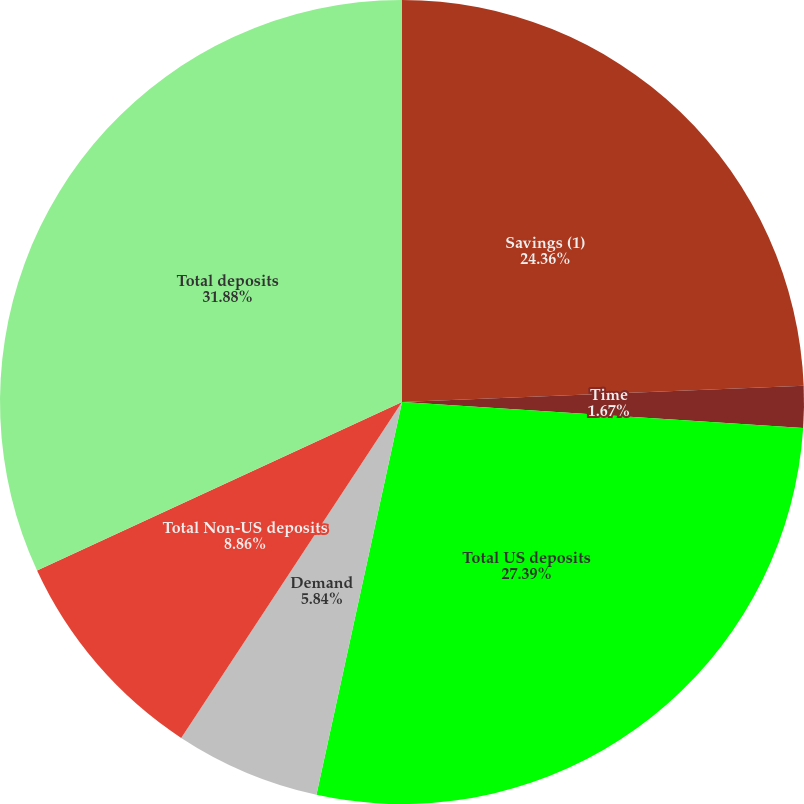Convert chart. <chart><loc_0><loc_0><loc_500><loc_500><pie_chart><fcel>Savings (1)<fcel>Time<fcel>Total US deposits<fcel>Demand<fcel>Total Non-US deposits<fcel>Total deposits<nl><fcel>24.36%<fcel>1.67%<fcel>27.39%<fcel>5.84%<fcel>8.86%<fcel>31.89%<nl></chart> 